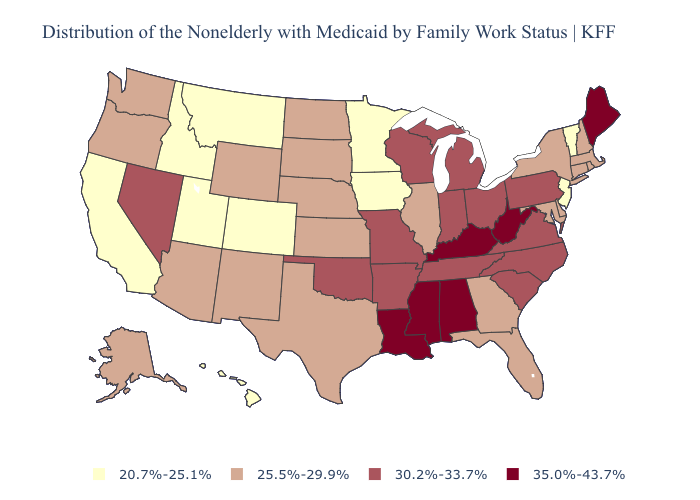Which states have the lowest value in the USA?
Quick response, please. California, Colorado, Hawaii, Idaho, Iowa, Minnesota, Montana, New Jersey, Utah, Vermont. What is the lowest value in the USA?
Be succinct. 20.7%-25.1%. What is the highest value in states that border Indiana?
Be succinct. 35.0%-43.7%. Name the states that have a value in the range 25.5%-29.9%?
Give a very brief answer. Alaska, Arizona, Connecticut, Delaware, Florida, Georgia, Illinois, Kansas, Maryland, Massachusetts, Nebraska, New Hampshire, New Mexico, New York, North Dakota, Oregon, Rhode Island, South Dakota, Texas, Washington, Wyoming. Among the states that border Arkansas , which have the lowest value?
Be succinct. Texas. Name the states that have a value in the range 35.0%-43.7%?
Concise answer only. Alabama, Kentucky, Louisiana, Maine, Mississippi, West Virginia. Does Washington have the same value as North Carolina?
Quick response, please. No. How many symbols are there in the legend?
Give a very brief answer. 4. What is the value of Pennsylvania?
Concise answer only. 30.2%-33.7%. Name the states that have a value in the range 20.7%-25.1%?
Quick response, please. California, Colorado, Hawaii, Idaho, Iowa, Minnesota, Montana, New Jersey, Utah, Vermont. Name the states that have a value in the range 35.0%-43.7%?
Short answer required. Alabama, Kentucky, Louisiana, Maine, Mississippi, West Virginia. Which states hav the highest value in the West?
Give a very brief answer. Nevada. What is the highest value in the USA?
Concise answer only. 35.0%-43.7%. What is the value of Missouri?
Concise answer only. 30.2%-33.7%. Name the states that have a value in the range 30.2%-33.7%?
Write a very short answer. Arkansas, Indiana, Michigan, Missouri, Nevada, North Carolina, Ohio, Oklahoma, Pennsylvania, South Carolina, Tennessee, Virginia, Wisconsin. 